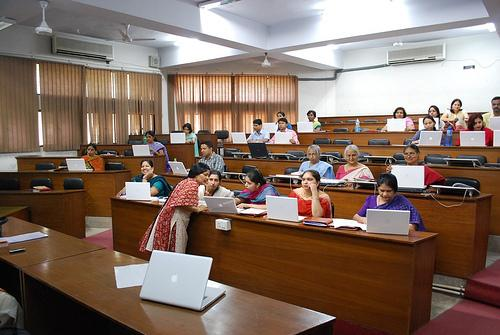Which country is this class most likely taught in?

Choices:
A) mexico
B) saudi arabia
C) india
D) china india 